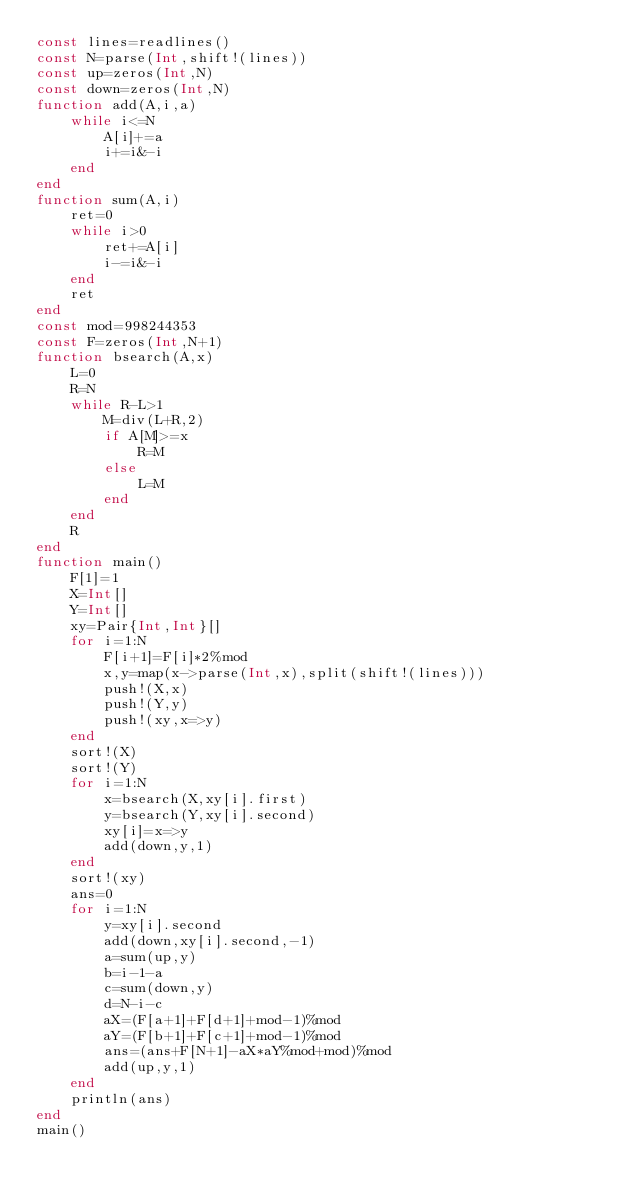Convert code to text. <code><loc_0><loc_0><loc_500><loc_500><_Julia_>const lines=readlines()
const N=parse(Int,shift!(lines))
const up=zeros(Int,N)
const down=zeros(Int,N)
function add(A,i,a)
	while i<=N
		A[i]+=a
		i+=i&-i
	end
end
function sum(A,i)
	ret=0
	while i>0
		ret+=A[i]
		i-=i&-i
	end
	ret
end
const mod=998244353
const F=zeros(Int,N+1)
function bsearch(A,x)
	L=0
	R=N
	while R-L>1
		M=div(L+R,2)
		if A[M]>=x
			R=M
		else
			L=M
		end
	end
	R
end
function main()
	F[1]=1
	X=Int[]
	Y=Int[]
	xy=Pair{Int,Int}[]
	for i=1:N
		F[i+1]=F[i]*2%mod
		x,y=map(x->parse(Int,x),split(shift!(lines)))
		push!(X,x)
		push!(Y,y)
		push!(xy,x=>y)
	end
	sort!(X)
	sort!(Y)
	for i=1:N
		x=bsearch(X,xy[i].first)
		y=bsearch(Y,xy[i].second)
		xy[i]=x=>y
		add(down,y,1)
	end
	sort!(xy)
	ans=0
	for i=1:N
		y=xy[i].second
		add(down,xy[i].second,-1)
		a=sum(up,y)
		b=i-1-a
		c=sum(down,y)
		d=N-i-c
		aX=(F[a+1]+F[d+1]+mod-1)%mod
		aY=(F[b+1]+F[c+1]+mod-1)%mod
		ans=(ans+F[N+1]-aX*aY%mod+mod)%mod
		add(up,y,1)
	end
	println(ans)
end
main()</code> 